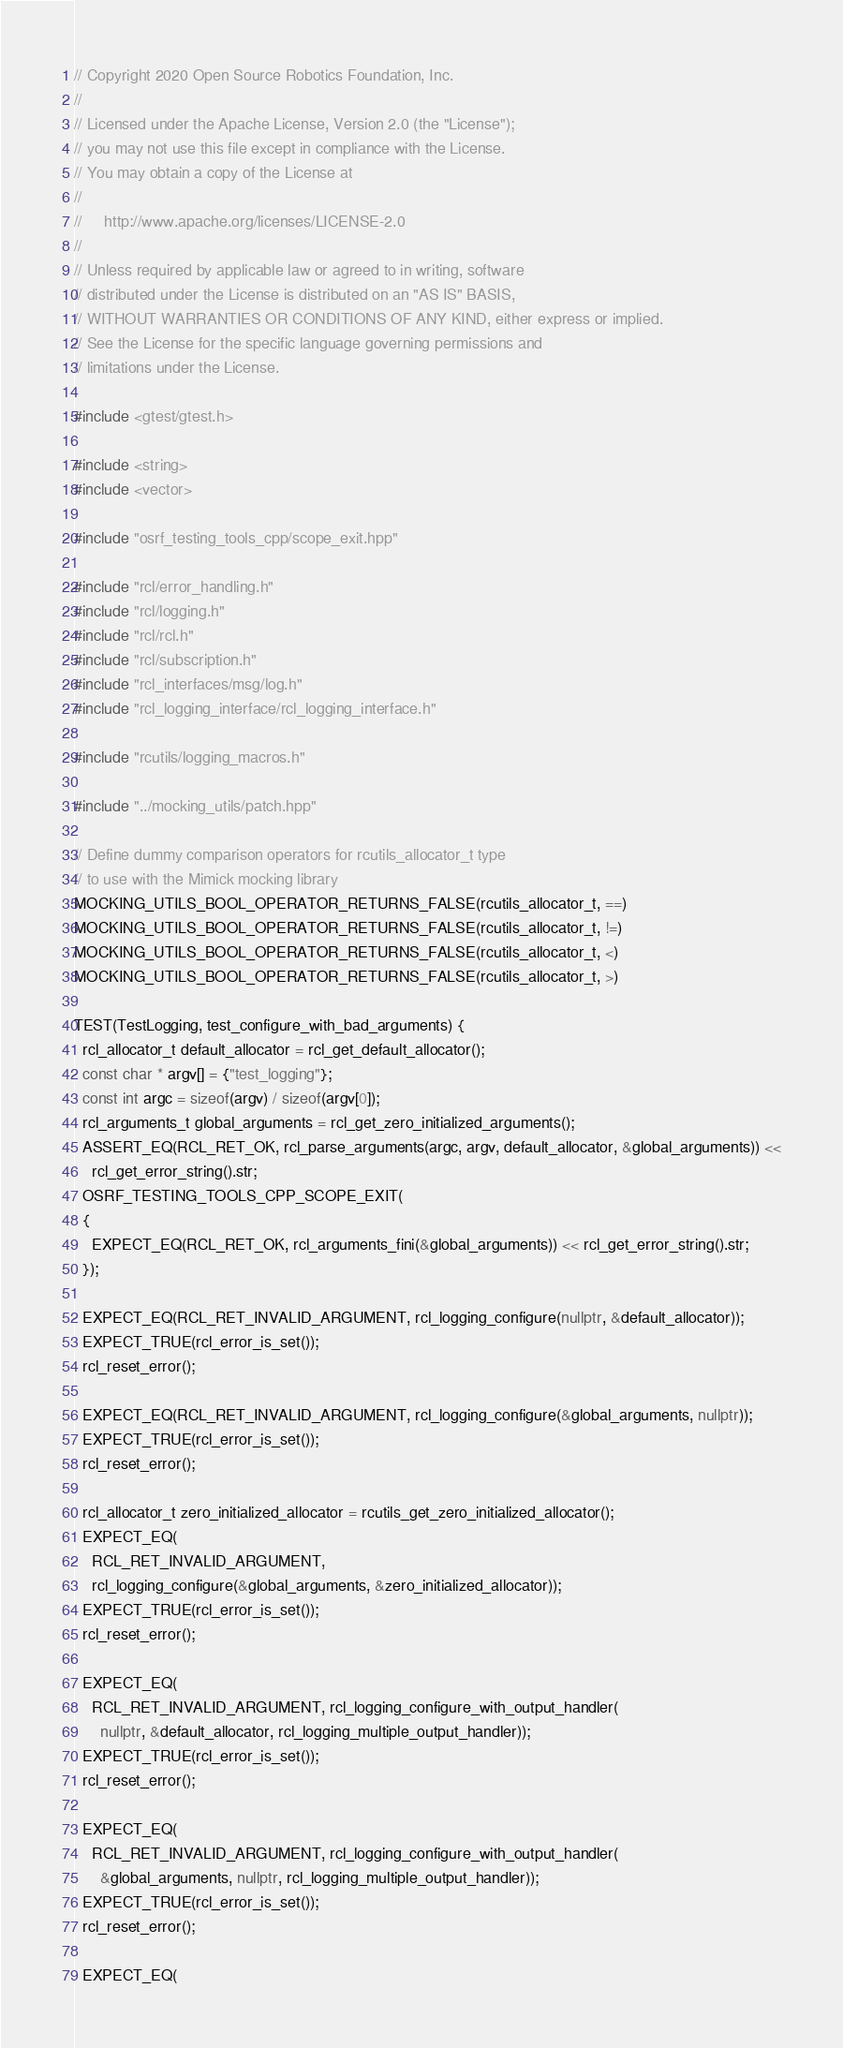Convert code to text. <code><loc_0><loc_0><loc_500><loc_500><_C++_>// Copyright 2020 Open Source Robotics Foundation, Inc.
//
// Licensed under the Apache License, Version 2.0 (the "License");
// you may not use this file except in compliance with the License.
// You may obtain a copy of the License at
//
//     http://www.apache.org/licenses/LICENSE-2.0
//
// Unless required by applicable law or agreed to in writing, software
// distributed under the License is distributed on an "AS IS" BASIS,
// WITHOUT WARRANTIES OR CONDITIONS OF ANY KIND, either express or implied.
// See the License for the specific language governing permissions and
// limitations under the License.

#include <gtest/gtest.h>

#include <string>
#include <vector>

#include "osrf_testing_tools_cpp/scope_exit.hpp"

#include "rcl/error_handling.h"
#include "rcl/logging.h"
#include "rcl/rcl.h"
#include "rcl/subscription.h"
#include "rcl_interfaces/msg/log.h"
#include "rcl_logging_interface/rcl_logging_interface.h"

#include "rcutils/logging_macros.h"

#include "../mocking_utils/patch.hpp"

// Define dummy comparison operators for rcutils_allocator_t type
// to use with the Mimick mocking library
MOCKING_UTILS_BOOL_OPERATOR_RETURNS_FALSE(rcutils_allocator_t, ==)
MOCKING_UTILS_BOOL_OPERATOR_RETURNS_FALSE(rcutils_allocator_t, !=)
MOCKING_UTILS_BOOL_OPERATOR_RETURNS_FALSE(rcutils_allocator_t, <)
MOCKING_UTILS_BOOL_OPERATOR_RETURNS_FALSE(rcutils_allocator_t, >)

TEST(TestLogging, test_configure_with_bad_arguments) {
  rcl_allocator_t default_allocator = rcl_get_default_allocator();
  const char * argv[] = {"test_logging"};
  const int argc = sizeof(argv) / sizeof(argv[0]);
  rcl_arguments_t global_arguments = rcl_get_zero_initialized_arguments();
  ASSERT_EQ(RCL_RET_OK, rcl_parse_arguments(argc, argv, default_allocator, &global_arguments)) <<
    rcl_get_error_string().str;
  OSRF_TESTING_TOOLS_CPP_SCOPE_EXIT(
  {
    EXPECT_EQ(RCL_RET_OK, rcl_arguments_fini(&global_arguments)) << rcl_get_error_string().str;
  });

  EXPECT_EQ(RCL_RET_INVALID_ARGUMENT, rcl_logging_configure(nullptr, &default_allocator));
  EXPECT_TRUE(rcl_error_is_set());
  rcl_reset_error();

  EXPECT_EQ(RCL_RET_INVALID_ARGUMENT, rcl_logging_configure(&global_arguments, nullptr));
  EXPECT_TRUE(rcl_error_is_set());
  rcl_reset_error();

  rcl_allocator_t zero_initialized_allocator = rcutils_get_zero_initialized_allocator();
  EXPECT_EQ(
    RCL_RET_INVALID_ARGUMENT,
    rcl_logging_configure(&global_arguments, &zero_initialized_allocator));
  EXPECT_TRUE(rcl_error_is_set());
  rcl_reset_error();

  EXPECT_EQ(
    RCL_RET_INVALID_ARGUMENT, rcl_logging_configure_with_output_handler(
      nullptr, &default_allocator, rcl_logging_multiple_output_handler));
  EXPECT_TRUE(rcl_error_is_set());
  rcl_reset_error();

  EXPECT_EQ(
    RCL_RET_INVALID_ARGUMENT, rcl_logging_configure_with_output_handler(
      &global_arguments, nullptr, rcl_logging_multiple_output_handler));
  EXPECT_TRUE(rcl_error_is_set());
  rcl_reset_error();

  EXPECT_EQ(</code> 